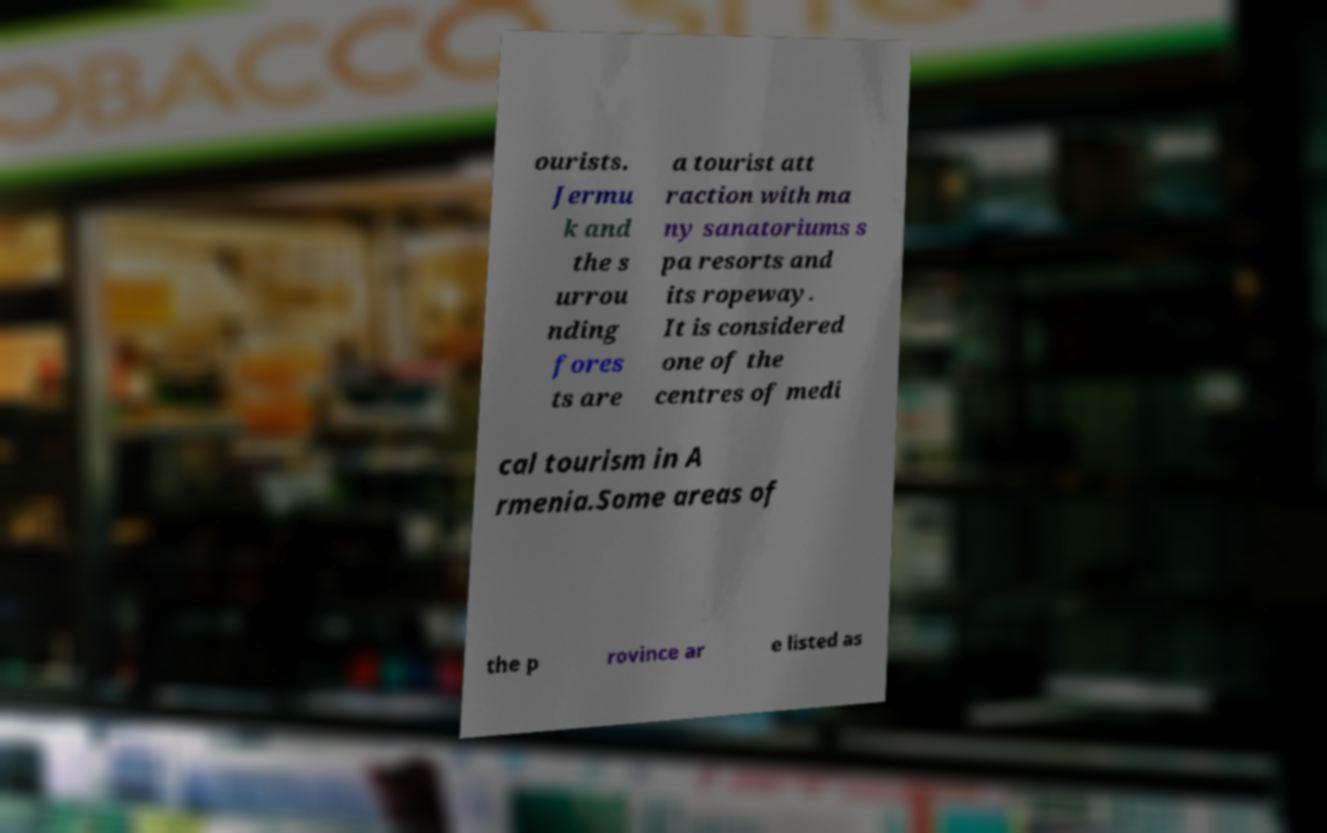I need the written content from this picture converted into text. Can you do that? ourists. Jermu k and the s urrou nding fores ts are a tourist att raction with ma ny sanatoriums s pa resorts and its ropeway. It is considered one of the centres of medi cal tourism in A rmenia.Some areas of the p rovince ar e listed as 